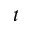<formula> <loc_0><loc_0><loc_500><loc_500>t</formula> 